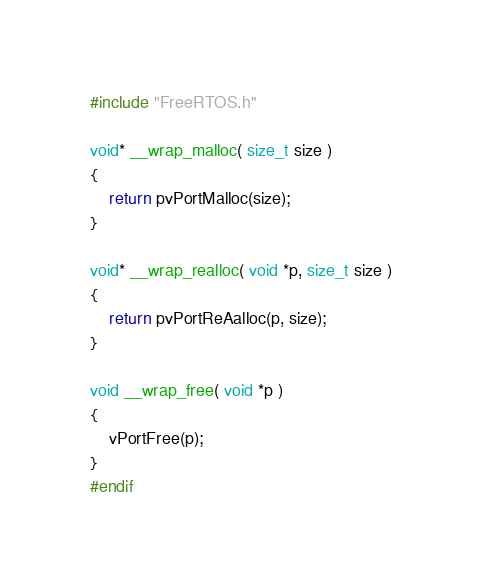<code> <loc_0><loc_0><loc_500><loc_500><_C_>#include "FreeRTOS.h"

void* __wrap_malloc( size_t size )
{
    return pvPortMalloc(size);
}

void* __wrap_realloc( void *p, size_t size )
{
    return pvPortReAalloc(p, size);
}

void __wrap_free( void *p )
{
    vPortFree(p);
}
#endif</code> 